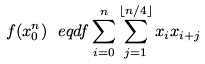Convert formula to latex. <formula><loc_0><loc_0><loc_500><loc_500>f ( x _ { 0 } ^ { n } ) \ e q d f \sum _ { i = 0 } ^ { n } \sum _ { j = 1 } ^ { \lfloor n / 4 \rfloor } x _ { i } x _ { i + j }</formula> 